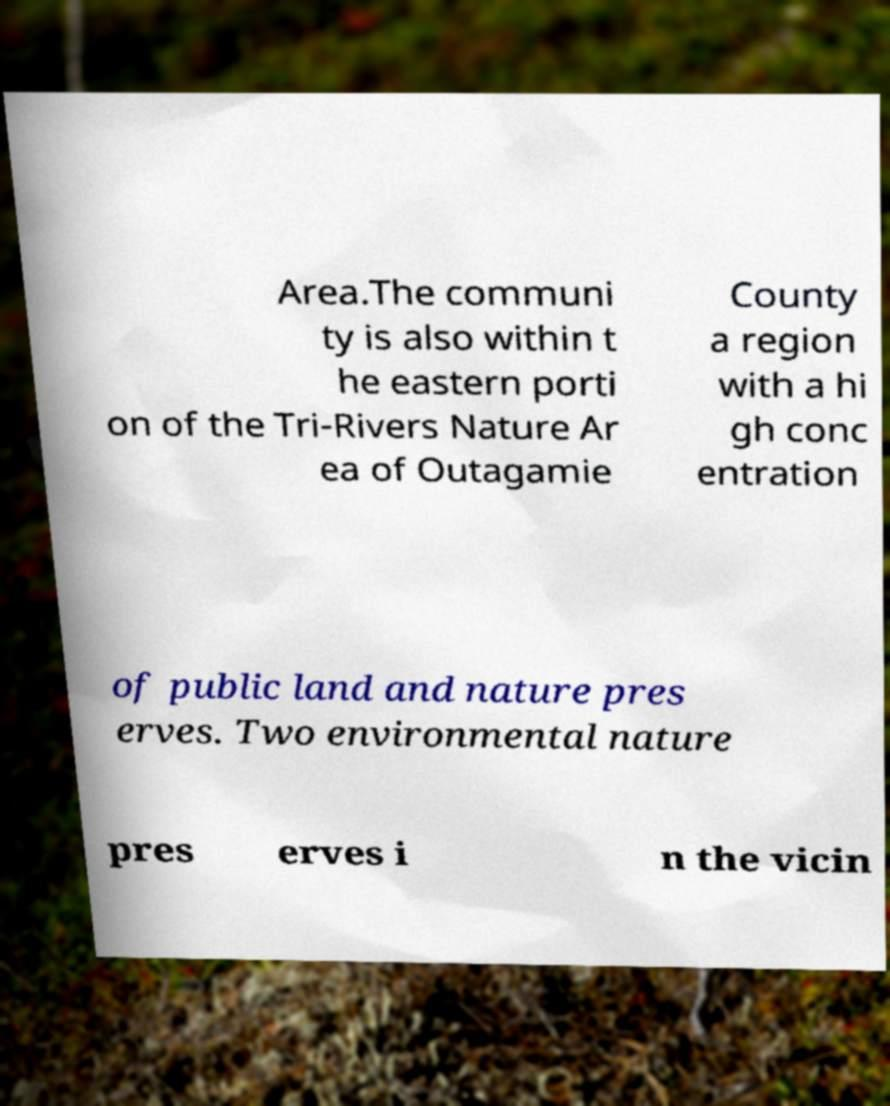Please identify and transcribe the text found in this image. Area.The communi ty is also within t he eastern porti on of the Tri-Rivers Nature Ar ea of Outagamie County a region with a hi gh conc entration of public land and nature pres erves. Two environmental nature pres erves i n the vicin 